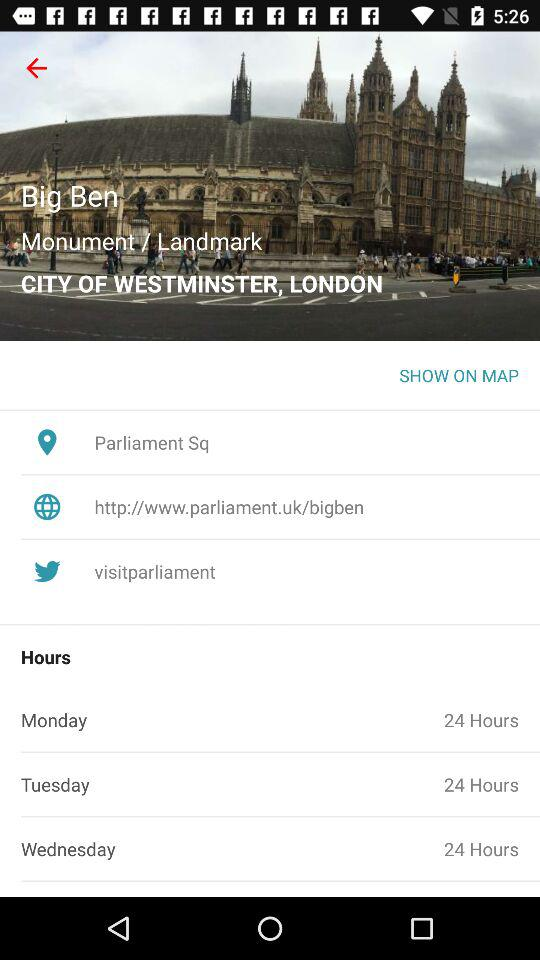What is the name of the shown monument? The name of the shown monument is "Big Ben". 